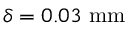<formula> <loc_0><loc_0><loc_500><loc_500>\delta = 0 . 0 3 \ m m</formula> 